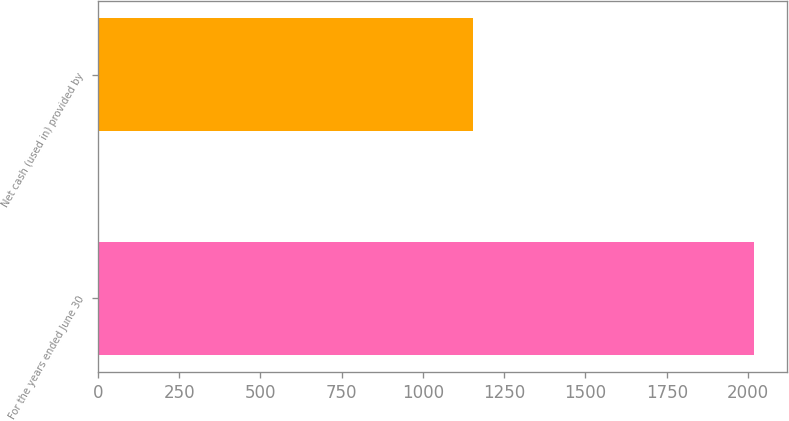Convert chart to OTSL. <chart><loc_0><loc_0><loc_500><loc_500><bar_chart><fcel>For the years ended June 30<fcel>Net cash (used in) provided by<nl><fcel>2019<fcel>1153<nl></chart> 